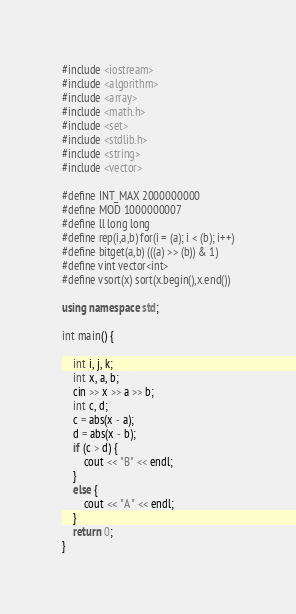<code> <loc_0><loc_0><loc_500><loc_500><_C++_>#include <iostream>
#include <algorithm>
#include <array>
#include <math.h>
#include <set>
#include <stdlib.h>
#include <string>
#include <vector>

#define INT_MAX 2000000000
#define MOD 1000000007
#define ll long long
#define rep(i,a,b) for(i = (a); i < (b); i++)
#define bitget(a,b) (((a) >> (b)) & 1)
#define vint vector<int>
#define vsort(x) sort(x.begin(),x.end())

using namespace std;

int main() {

	int i, j, k;
	int x, a, b;
	cin >> x >> a >> b;
	int c, d;
	c = abs(x - a);
	d = abs(x - b);
	if (c > d) {
		cout << "B" << endl;
	}
	else {
		cout << "A" << endl;
	}
	return 0;
}</code> 